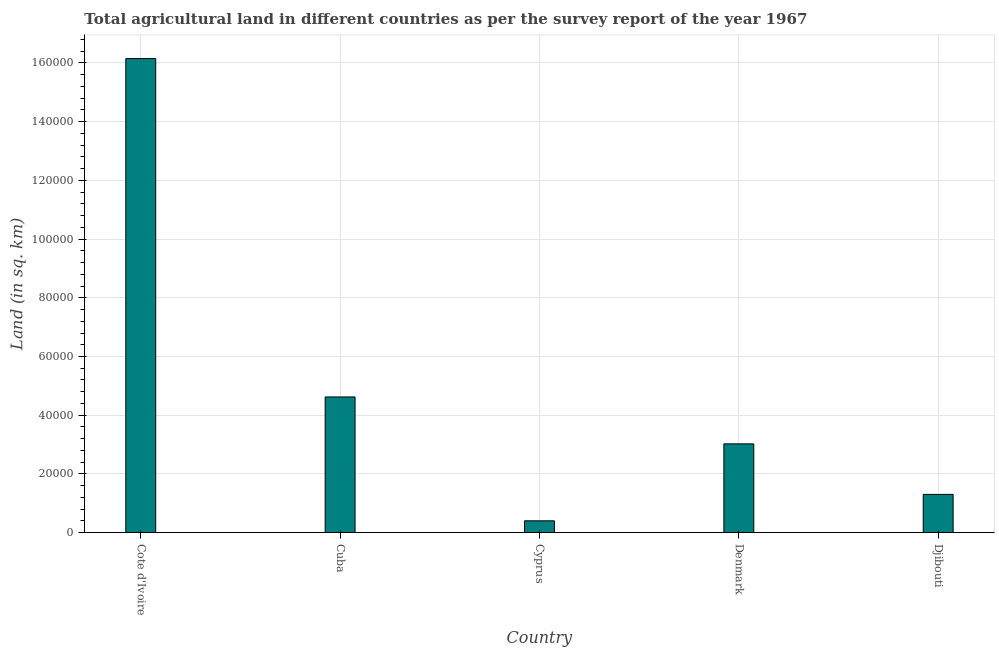Does the graph contain any zero values?
Make the answer very short. No. Does the graph contain grids?
Give a very brief answer. Yes. What is the title of the graph?
Your answer should be very brief. Total agricultural land in different countries as per the survey report of the year 1967. What is the label or title of the X-axis?
Ensure brevity in your answer.  Country. What is the label or title of the Y-axis?
Make the answer very short. Land (in sq. km). What is the agricultural land in Cuba?
Give a very brief answer. 4.62e+04. Across all countries, what is the maximum agricultural land?
Give a very brief answer. 1.62e+05. Across all countries, what is the minimum agricultural land?
Your answer should be compact. 4010. In which country was the agricultural land maximum?
Your answer should be very brief. Cote d'Ivoire. In which country was the agricultural land minimum?
Provide a short and direct response. Cyprus. What is the sum of the agricultural land?
Give a very brief answer. 2.55e+05. What is the difference between the agricultural land in Cote d'Ivoire and Djibouti?
Make the answer very short. 1.48e+05. What is the average agricultural land per country?
Give a very brief answer. 5.10e+04. What is the median agricultural land?
Keep it short and to the point. 3.02e+04. In how many countries, is the agricultural land greater than 40000 sq. km?
Your answer should be compact. 2. What is the ratio of the agricultural land in Cyprus to that in Djibouti?
Provide a short and direct response. 0.31. Is the agricultural land in Cyprus less than that in Denmark?
Provide a short and direct response. Yes. What is the difference between the highest and the second highest agricultural land?
Offer a very short reply. 1.15e+05. Is the sum of the agricultural land in Cuba and Denmark greater than the maximum agricultural land across all countries?
Make the answer very short. No. What is the difference between the highest and the lowest agricultural land?
Your answer should be very brief. 1.57e+05. How many bars are there?
Your answer should be very brief. 5. How many countries are there in the graph?
Offer a terse response. 5. What is the Land (in sq. km) of Cote d'Ivoire?
Keep it short and to the point. 1.62e+05. What is the Land (in sq. km) in Cuba?
Keep it short and to the point. 4.62e+04. What is the Land (in sq. km) of Cyprus?
Your answer should be very brief. 4010. What is the Land (in sq. km) in Denmark?
Provide a short and direct response. 3.02e+04. What is the Land (in sq. km) of Djibouti?
Your answer should be very brief. 1.30e+04. What is the difference between the Land (in sq. km) in Cote d'Ivoire and Cuba?
Ensure brevity in your answer.  1.15e+05. What is the difference between the Land (in sq. km) in Cote d'Ivoire and Cyprus?
Offer a terse response. 1.57e+05. What is the difference between the Land (in sq. km) in Cote d'Ivoire and Denmark?
Offer a terse response. 1.31e+05. What is the difference between the Land (in sq. km) in Cote d'Ivoire and Djibouti?
Offer a terse response. 1.48e+05. What is the difference between the Land (in sq. km) in Cuba and Cyprus?
Give a very brief answer. 4.22e+04. What is the difference between the Land (in sq. km) in Cuba and Denmark?
Your answer should be very brief. 1.60e+04. What is the difference between the Land (in sq. km) in Cuba and Djibouti?
Provide a succinct answer. 3.32e+04. What is the difference between the Land (in sq. km) in Cyprus and Denmark?
Provide a succinct answer. -2.62e+04. What is the difference between the Land (in sq. km) in Cyprus and Djibouti?
Your answer should be compact. -9000. What is the difference between the Land (in sq. km) in Denmark and Djibouti?
Give a very brief answer. 1.72e+04. What is the ratio of the Land (in sq. km) in Cote d'Ivoire to that in Cuba?
Give a very brief answer. 3.5. What is the ratio of the Land (in sq. km) in Cote d'Ivoire to that in Cyprus?
Give a very brief answer. 40.27. What is the ratio of the Land (in sq. km) in Cote d'Ivoire to that in Denmark?
Provide a succinct answer. 5.34. What is the ratio of the Land (in sq. km) in Cote d'Ivoire to that in Djibouti?
Keep it short and to the point. 12.41. What is the ratio of the Land (in sq. km) in Cuba to that in Cyprus?
Your response must be concise. 11.52. What is the ratio of the Land (in sq. km) in Cuba to that in Denmark?
Offer a terse response. 1.53. What is the ratio of the Land (in sq. km) in Cuba to that in Djibouti?
Provide a succinct answer. 3.55. What is the ratio of the Land (in sq. km) in Cyprus to that in Denmark?
Offer a terse response. 0.13. What is the ratio of the Land (in sq. km) in Cyprus to that in Djibouti?
Your answer should be compact. 0.31. What is the ratio of the Land (in sq. km) in Denmark to that in Djibouti?
Give a very brief answer. 2.32. 